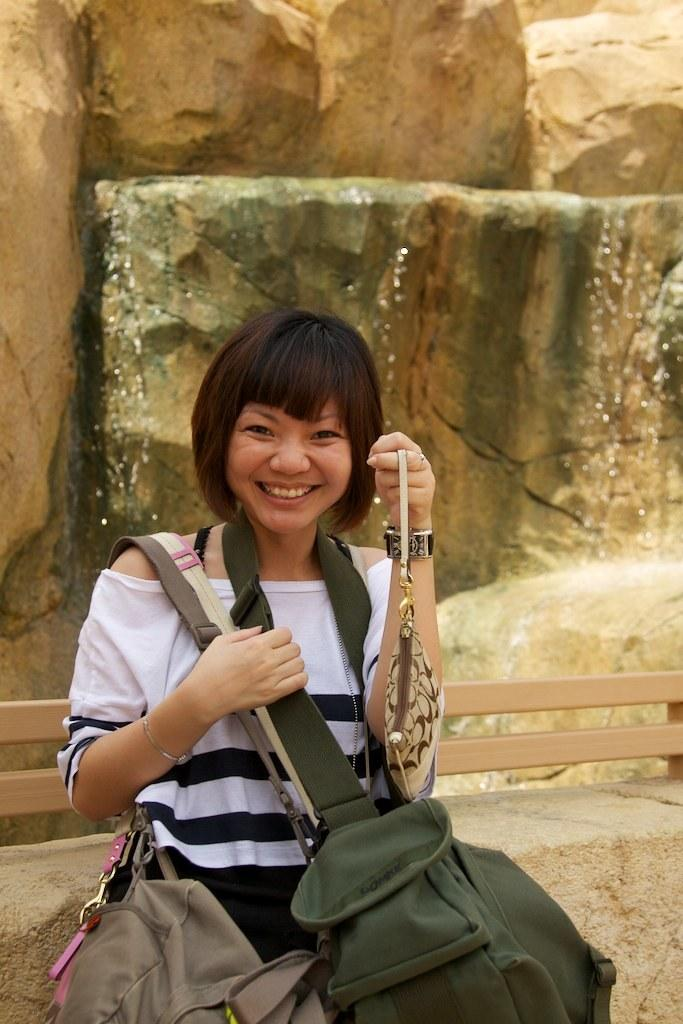Who is the main subject in the image? There is a woman in the image. What is the woman doing in the image? The woman is standing. What is the woman wearing in the image? The woman is wearing bags. What can be seen in the background of the image? There are rocks in the background of the image. What color is the crayon the woman is holding in the image? There is no crayon present in the image. How much lead is visible in the woman's teeth in the image? There is no indication of the woman's teeth or any lead in the image. 